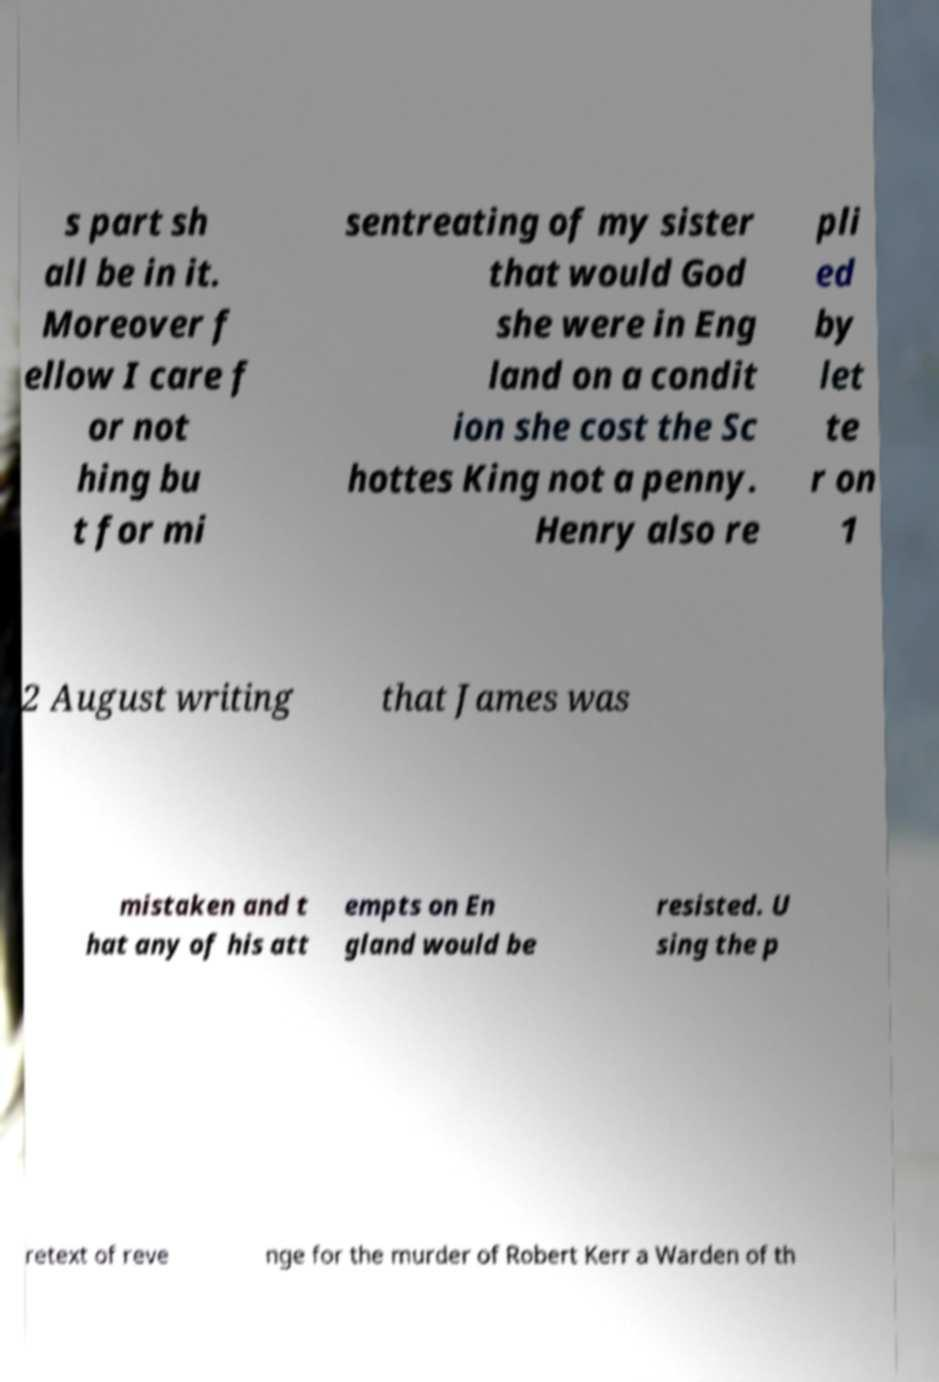I need the written content from this picture converted into text. Can you do that? s part sh all be in it. Moreover f ellow I care f or not hing bu t for mi sentreating of my sister that would God she were in Eng land on a condit ion she cost the Sc hottes King not a penny. Henry also re pli ed by let te r on 1 2 August writing that James was mistaken and t hat any of his att empts on En gland would be resisted. U sing the p retext of reve nge for the murder of Robert Kerr a Warden of th 